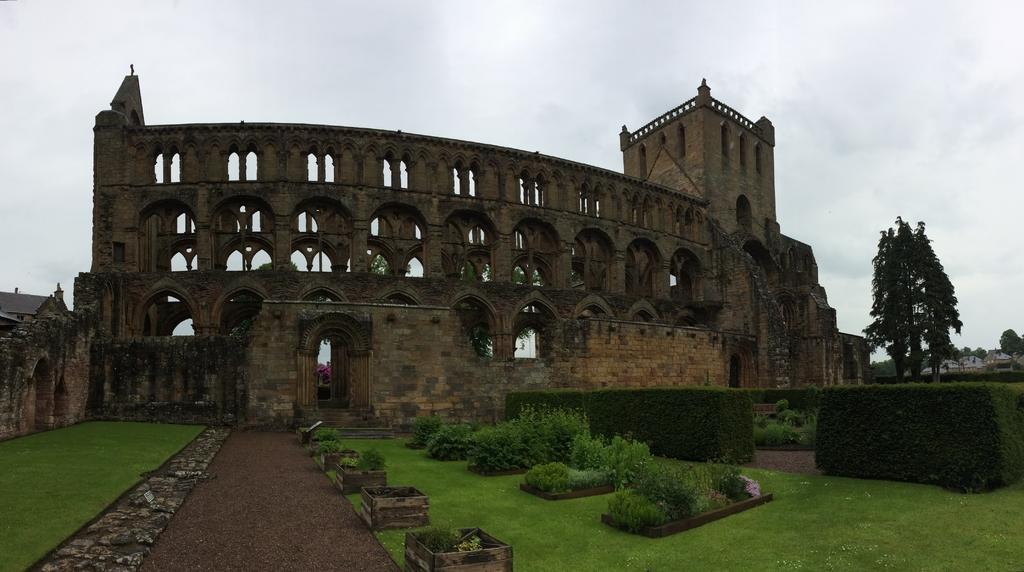What type of structure is in the image? There is a fort in the image. What is in front of the fort? There is a wall in front of the fort. What is at the bottom of the image? There is a ground at the bottom of the image. What can be seen to the right of the image? There are trees to the right of the image. What is visible at the top of the image? There are clouds in the sky at the top of the image. What type of cord is used to hold the gold in the image? There is no cord or gold present in the image; it features a fort, wall, ground, trees, and clouds. 